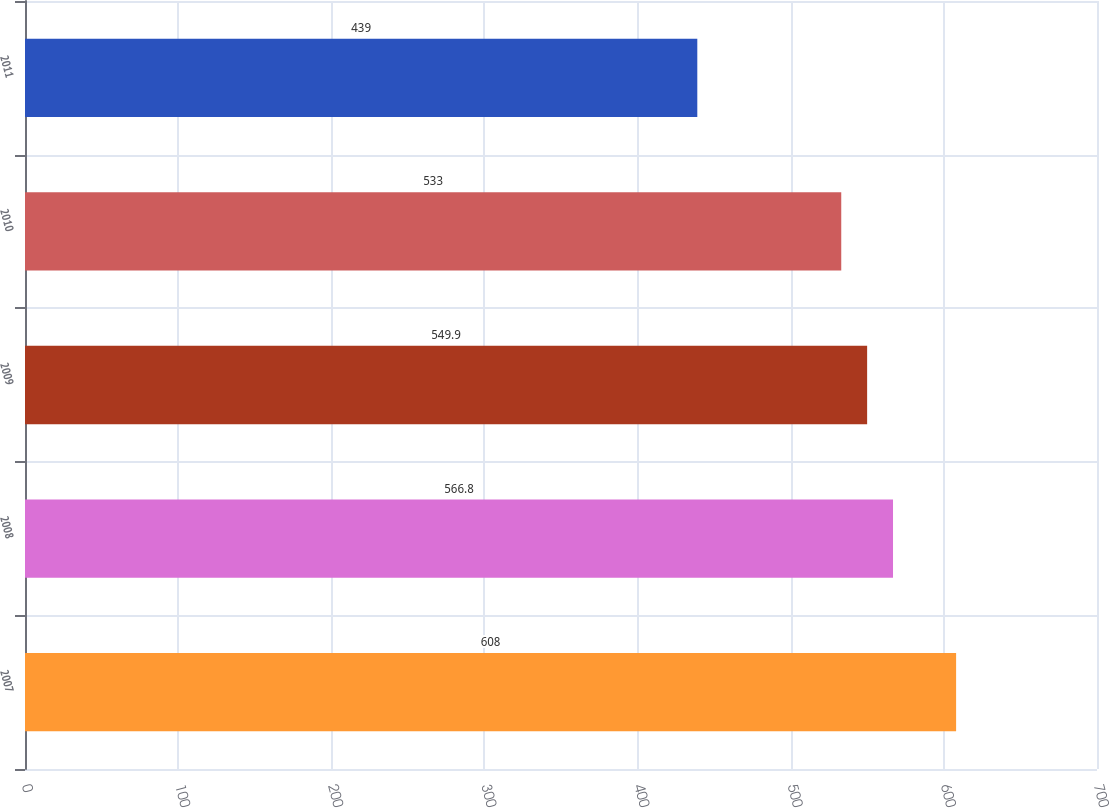Convert chart to OTSL. <chart><loc_0><loc_0><loc_500><loc_500><bar_chart><fcel>2007<fcel>2008<fcel>2009<fcel>2010<fcel>2011<nl><fcel>608<fcel>566.8<fcel>549.9<fcel>533<fcel>439<nl></chart> 